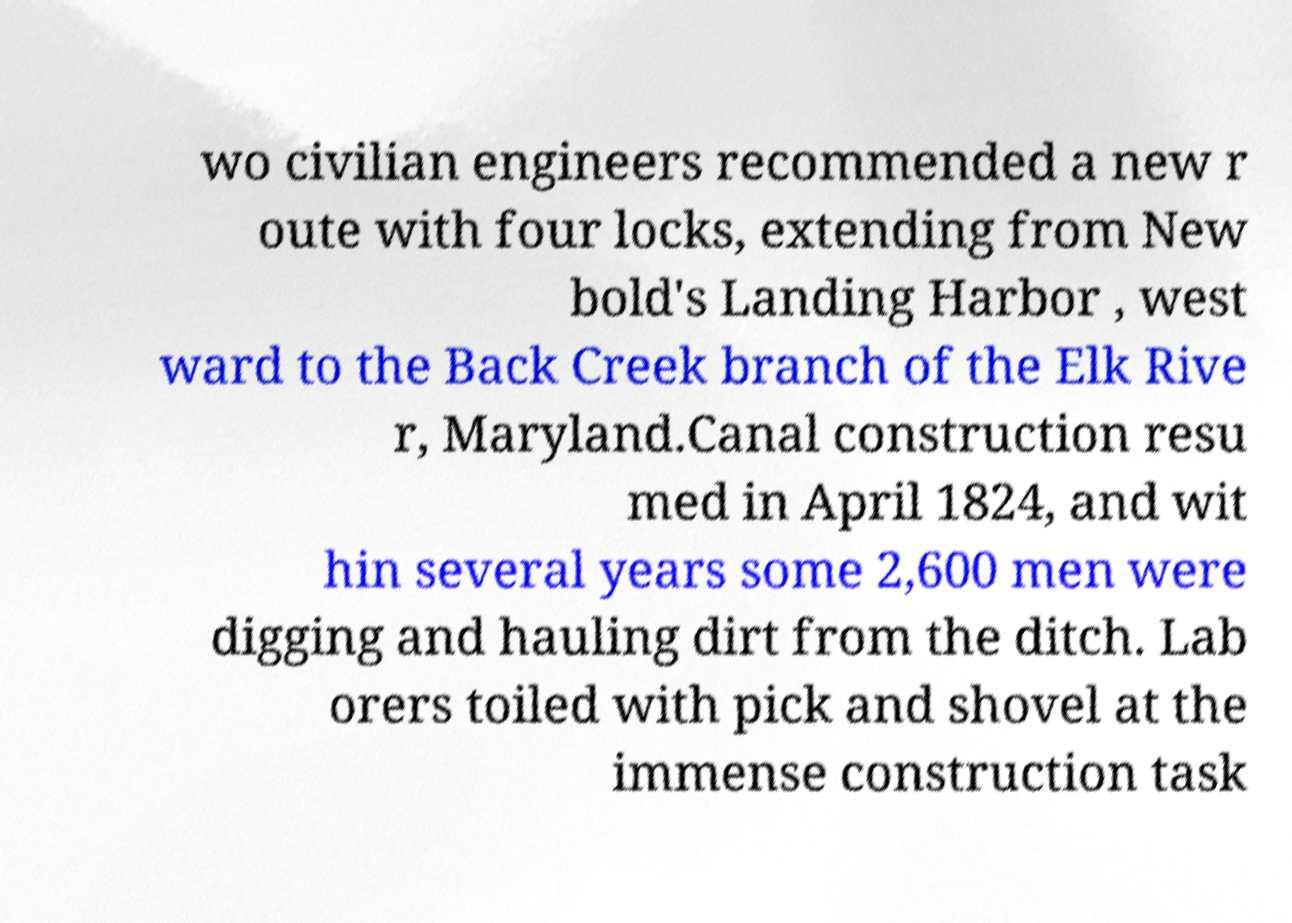Can you accurately transcribe the text from the provided image for me? wo civilian engineers recommended a new r oute with four locks, extending from New bold's Landing Harbor , west ward to the Back Creek branch of the Elk Rive r, Maryland.Canal construction resu med in April 1824, and wit hin several years some 2,600 men were digging and hauling dirt from the ditch. Lab orers toiled with pick and shovel at the immense construction task 